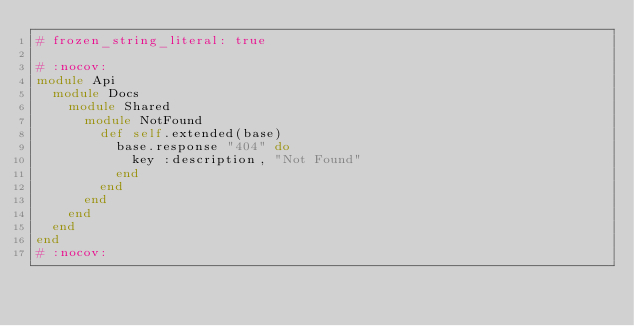Convert code to text. <code><loc_0><loc_0><loc_500><loc_500><_Ruby_># frozen_string_literal: true

# :nocov:
module Api
  module Docs
    module Shared
      module NotFound
        def self.extended(base)
          base.response "404" do
            key :description, "Not Found"
          end
        end
      end
    end
  end
end
# :nocov:
</code> 